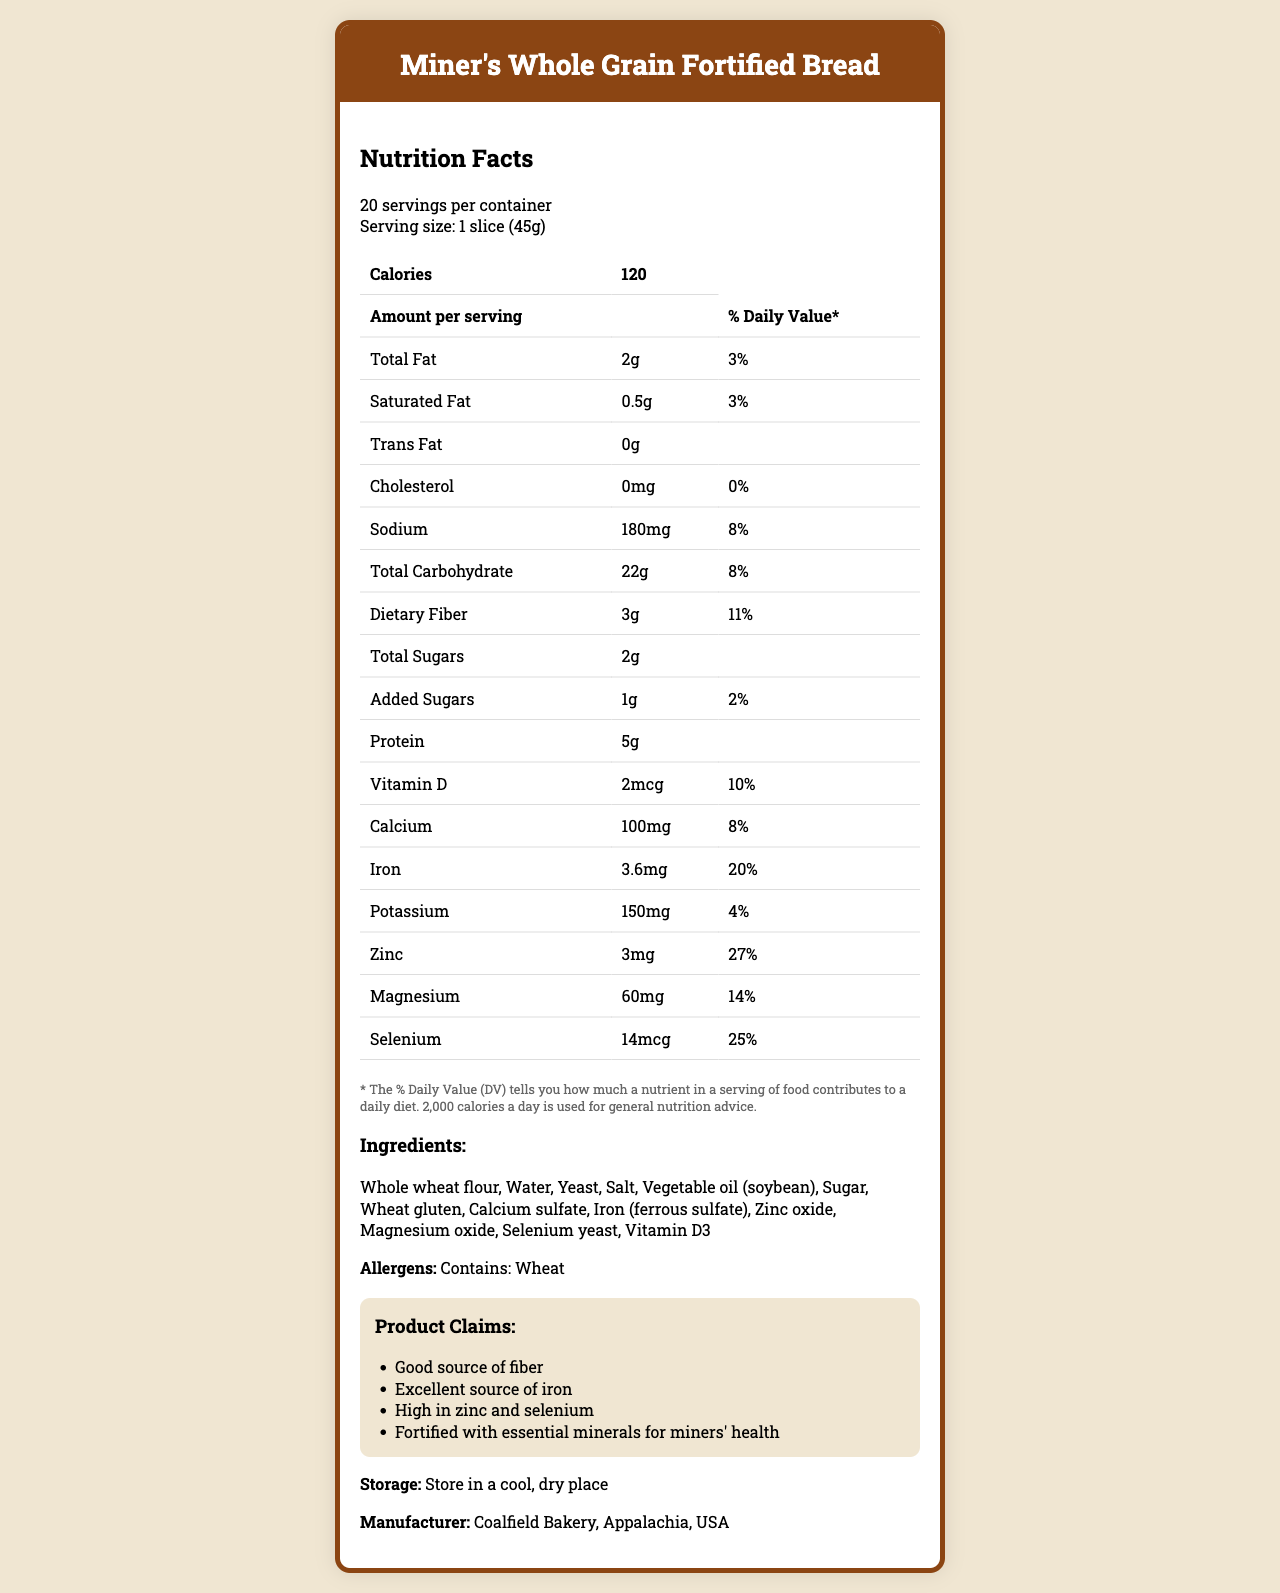what is the total fat per serving? The document states that the amount of total fat per serving is 2g.
Answer: 2g what is the amount of protein per slice? The document mentions that the amount of protein per serving (1 slice) is 5g.
Answer: 5g which ingredient is the third listed? The ingredients are listed sequentially: "Whole wheat flour," "Water," "Yeast," etc.
Answer: Yeast how many calories are there in two slices? Each slice has 120 calories, so two slices have 120 calories x 2 = 240 calories.
Answer: 240 calories what is the manufacturer of this bread? The document specifies that the manufacturer is Coalfield Bakery located in Appalachia, USA.
Answer: Coalfield Bakery, Appalachia, USA how much iron does one slice contain? A. 1mg B. 3.6mg C. 5mg D. 4.2mg The document shows that one slice contains 3.6mg of iron.
Answer: B what percentage of the daily value does selenium account for? A. 15% B. 20% C. 25% D. 30% The document lists selenium with a daily value percentage of 25%.
Answer: C is this bread a good source of fiber? The document includes a product claim that this bread is a "Good source of fiber."
Answer: Yes Can you find out if this bread contains peanuts? The document lists wheat as an allergen but does not provide any information about peanuts.
Answer: Cannot be determined summarize the main function and purpose of this document. This document serves to inform consumers, particularly those interested in a diet beneficial for their occupational health, about the nutritional value and specific health benefits of the bread.
Answer: The document provides detailed nutritional information about Miner's Whole Grain Fortified Bread, including serving size, calories, and nutritional content per serving. It also lists the ingredients, allergens, manufacturer, storage instructions, and relevant health claims for consumers, with a focus on minerals essential for miners' diets. 